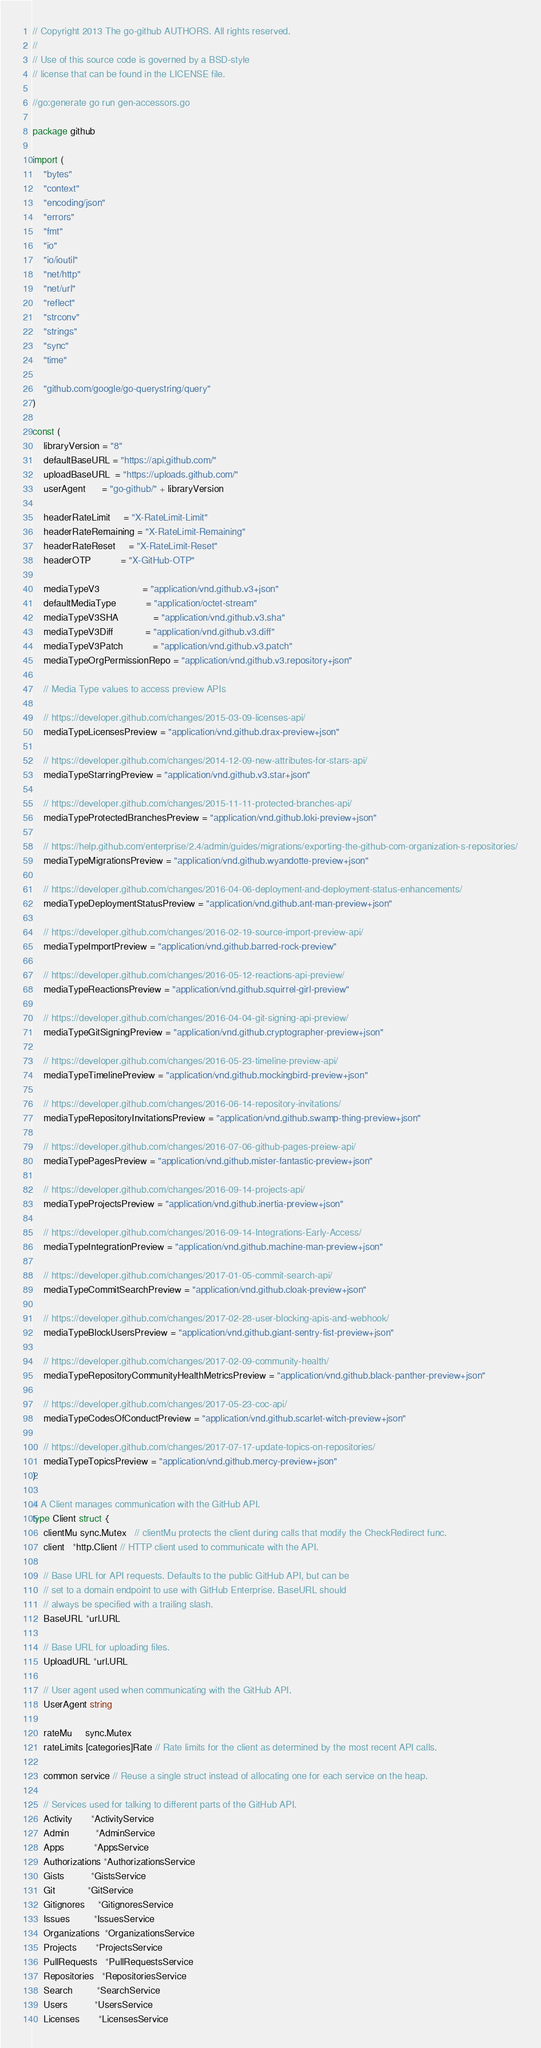<code> <loc_0><loc_0><loc_500><loc_500><_Go_>// Copyright 2013 The go-github AUTHORS. All rights reserved.
//
// Use of this source code is governed by a BSD-style
// license that can be found in the LICENSE file.

//go:generate go run gen-accessors.go

package github

import (
	"bytes"
	"context"
	"encoding/json"
	"errors"
	"fmt"
	"io"
	"io/ioutil"
	"net/http"
	"net/url"
	"reflect"
	"strconv"
	"strings"
	"sync"
	"time"

	"github.com/google/go-querystring/query"
)

const (
	libraryVersion = "8"
	defaultBaseURL = "https://api.github.com/"
	uploadBaseURL  = "https://uploads.github.com/"
	userAgent      = "go-github/" + libraryVersion

	headerRateLimit     = "X-RateLimit-Limit"
	headerRateRemaining = "X-RateLimit-Remaining"
	headerRateReset     = "X-RateLimit-Reset"
	headerOTP           = "X-GitHub-OTP"

	mediaTypeV3                = "application/vnd.github.v3+json"
	defaultMediaType           = "application/octet-stream"
	mediaTypeV3SHA             = "application/vnd.github.v3.sha"
	mediaTypeV3Diff            = "application/vnd.github.v3.diff"
	mediaTypeV3Patch           = "application/vnd.github.v3.patch"
	mediaTypeOrgPermissionRepo = "application/vnd.github.v3.repository+json"

	// Media Type values to access preview APIs

	// https://developer.github.com/changes/2015-03-09-licenses-api/
	mediaTypeLicensesPreview = "application/vnd.github.drax-preview+json"

	// https://developer.github.com/changes/2014-12-09-new-attributes-for-stars-api/
	mediaTypeStarringPreview = "application/vnd.github.v3.star+json"

	// https://developer.github.com/changes/2015-11-11-protected-branches-api/
	mediaTypeProtectedBranchesPreview = "application/vnd.github.loki-preview+json"

	// https://help.github.com/enterprise/2.4/admin/guides/migrations/exporting-the-github-com-organization-s-repositories/
	mediaTypeMigrationsPreview = "application/vnd.github.wyandotte-preview+json"

	// https://developer.github.com/changes/2016-04-06-deployment-and-deployment-status-enhancements/
	mediaTypeDeploymentStatusPreview = "application/vnd.github.ant-man-preview+json"

	// https://developer.github.com/changes/2016-02-19-source-import-preview-api/
	mediaTypeImportPreview = "application/vnd.github.barred-rock-preview"

	// https://developer.github.com/changes/2016-05-12-reactions-api-preview/
	mediaTypeReactionsPreview = "application/vnd.github.squirrel-girl-preview"

	// https://developer.github.com/changes/2016-04-04-git-signing-api-preview/
	mediaTypeGitSigningPreview = "application/vnd.github.cryptographer-preview+json"

	// https://developer.github.com/changes/2016-05-23-timeline-preview-api/
	mediaTypeTimelinePreview = "application/vnd.github.mockingbird-preview+json"

	// https://developer.github.com/changes/2016-06-14-repository-invitations/
	mediaTypeRepositoryInvitationsPreview = "application/vnd.github.swamp-thing-preview+json"

	// https://developer.github.com/changes/2016-07-06-github-pages-preiew-api/
	mediaTypePagesPreview = "application/vnd.github.mister-fantastic-preview+json"

	// https://developer.github.com/changes/2016-09-14-projects-api/
	mediaTypeProjectsPreview = "application/vnd.github.inertia-preview+json"

	// https://developer.github.com/changes/2016-09-14-Integrations-Early-Access/
	mediaTypeIntegrationPreview = "application/vnd.github.machine-man-preview+json"

	// https://developer.github.com/changes/2017-01-05-commit-search-api/
	mediaTypeCommitSearchPreview = "application/vnd.github.cloak-preview+json"

	// https://developer.github.com/changes/2017-02-28-user-blocking-apis-and-webhook/
	mediaTypeBlockUsersPreview = "application/vnd.github.giant-sentry-fist-preview+json"

	// https://developer.github.com/changes/2017-02-09-community-health/
	mediaTypeRepositoryCommunityHealthMetricsPreview = "application/vnd.github.black-panther-preview+json"

	// https://developer.github.com/changes/2017-05-23-coc-api/
	mediaTypeCodesOfConductPreview = "application/vnd.github.scarlet-witch-preview+json"

	// https://developer.github.com/changes/2017-07-17-update-topics-on-repositories/
	mediaTypeTopicsPreview = "application/vnd.github.mercy-preview+json"
)

// A Client manages communication with the GitHub API.
type Client struct {
	clientMu sync.Mutex   // clientMu protects the client during calls that modify the CheckRedirect func.
	client   *http.Client // HTTP client used to communicate with the API.

	// Base URL for API requests. Defaults to the public GitHub API, but can be
	// set to a domain endpoint to use with GitHub Enterprise. BaseURL should
	// always be specified with a trailing slash.
	BaseURL *url.URL

	// Base URL for uploading files.
	UploadURL *url.URL

	// User agent used when communicating with the GitHub API.
	UserAgent string

	rateMu     sync.Mutex
	rateLimits [categories]Rate // Rate limits for the client as determined by the most recent API calls.

	common service // Reuse a single struct instead of allocating one for each service on the heap.

	// Services used for talking to different parts of the GitHub API.
	Activity       *ActivityService
	Admin          *AdminService
	Apps           *AppsService
	Authorizations *AuthorizationsService
	Gists          *GistsService
	Git            *GitService
	Gitignores     *GitignoresService
	Issues         *IssuesService
	Organizations  *OrganizationsService
	Projects       *ProjectsService
	PullRequests   *PullRequestsService
	Repositories   *RepositoriesService
	Search         *SearchService
	Users          *UsersService
	Licenses       *LicensesService</code> 